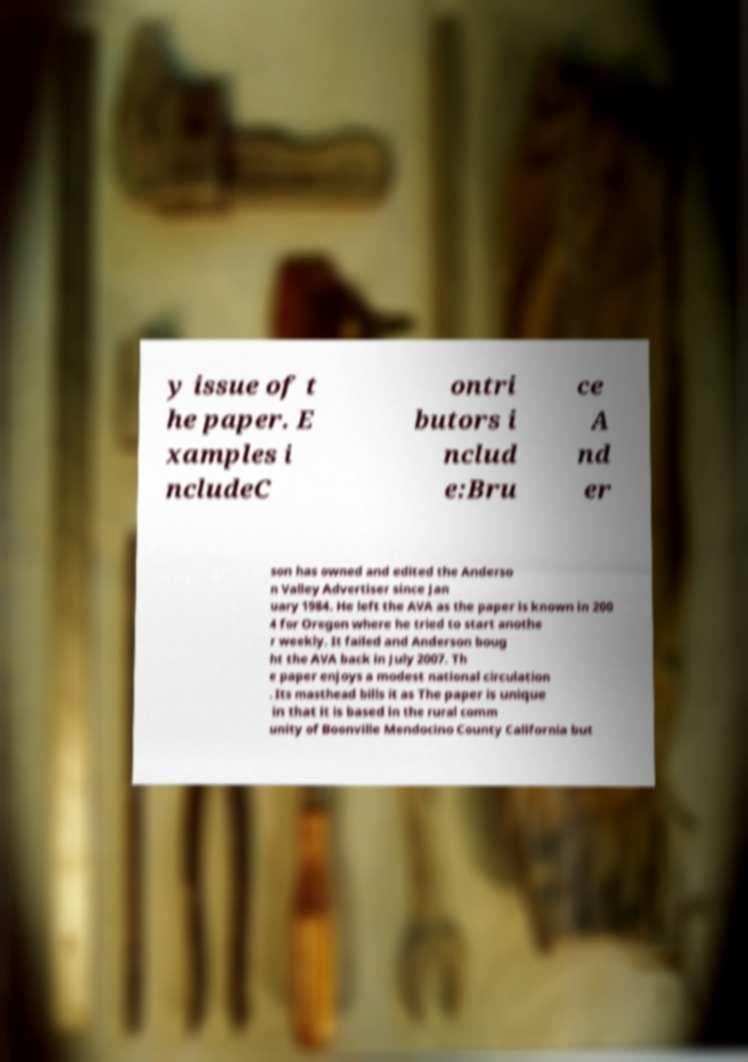Can you accurately transcribe the text from the provided image for me? y issue of t he paper. E xamples i ncludeC ontri butors i nclud e:Bru ce A nd er son has owned and edited the Anderso n Valley Advertiser since Jan uary 1984. He left the AVA as the paper is known in 200 4 for Oregon where he tried to start anothe r weekly. It failed and Anderson boug ht the AVA back in July 2007. Th e paper enjoys a modest national circulation . Its masthead bills it as The paper is unique in that it is based in the rural comm unity of Boonville Mendocino County California but 